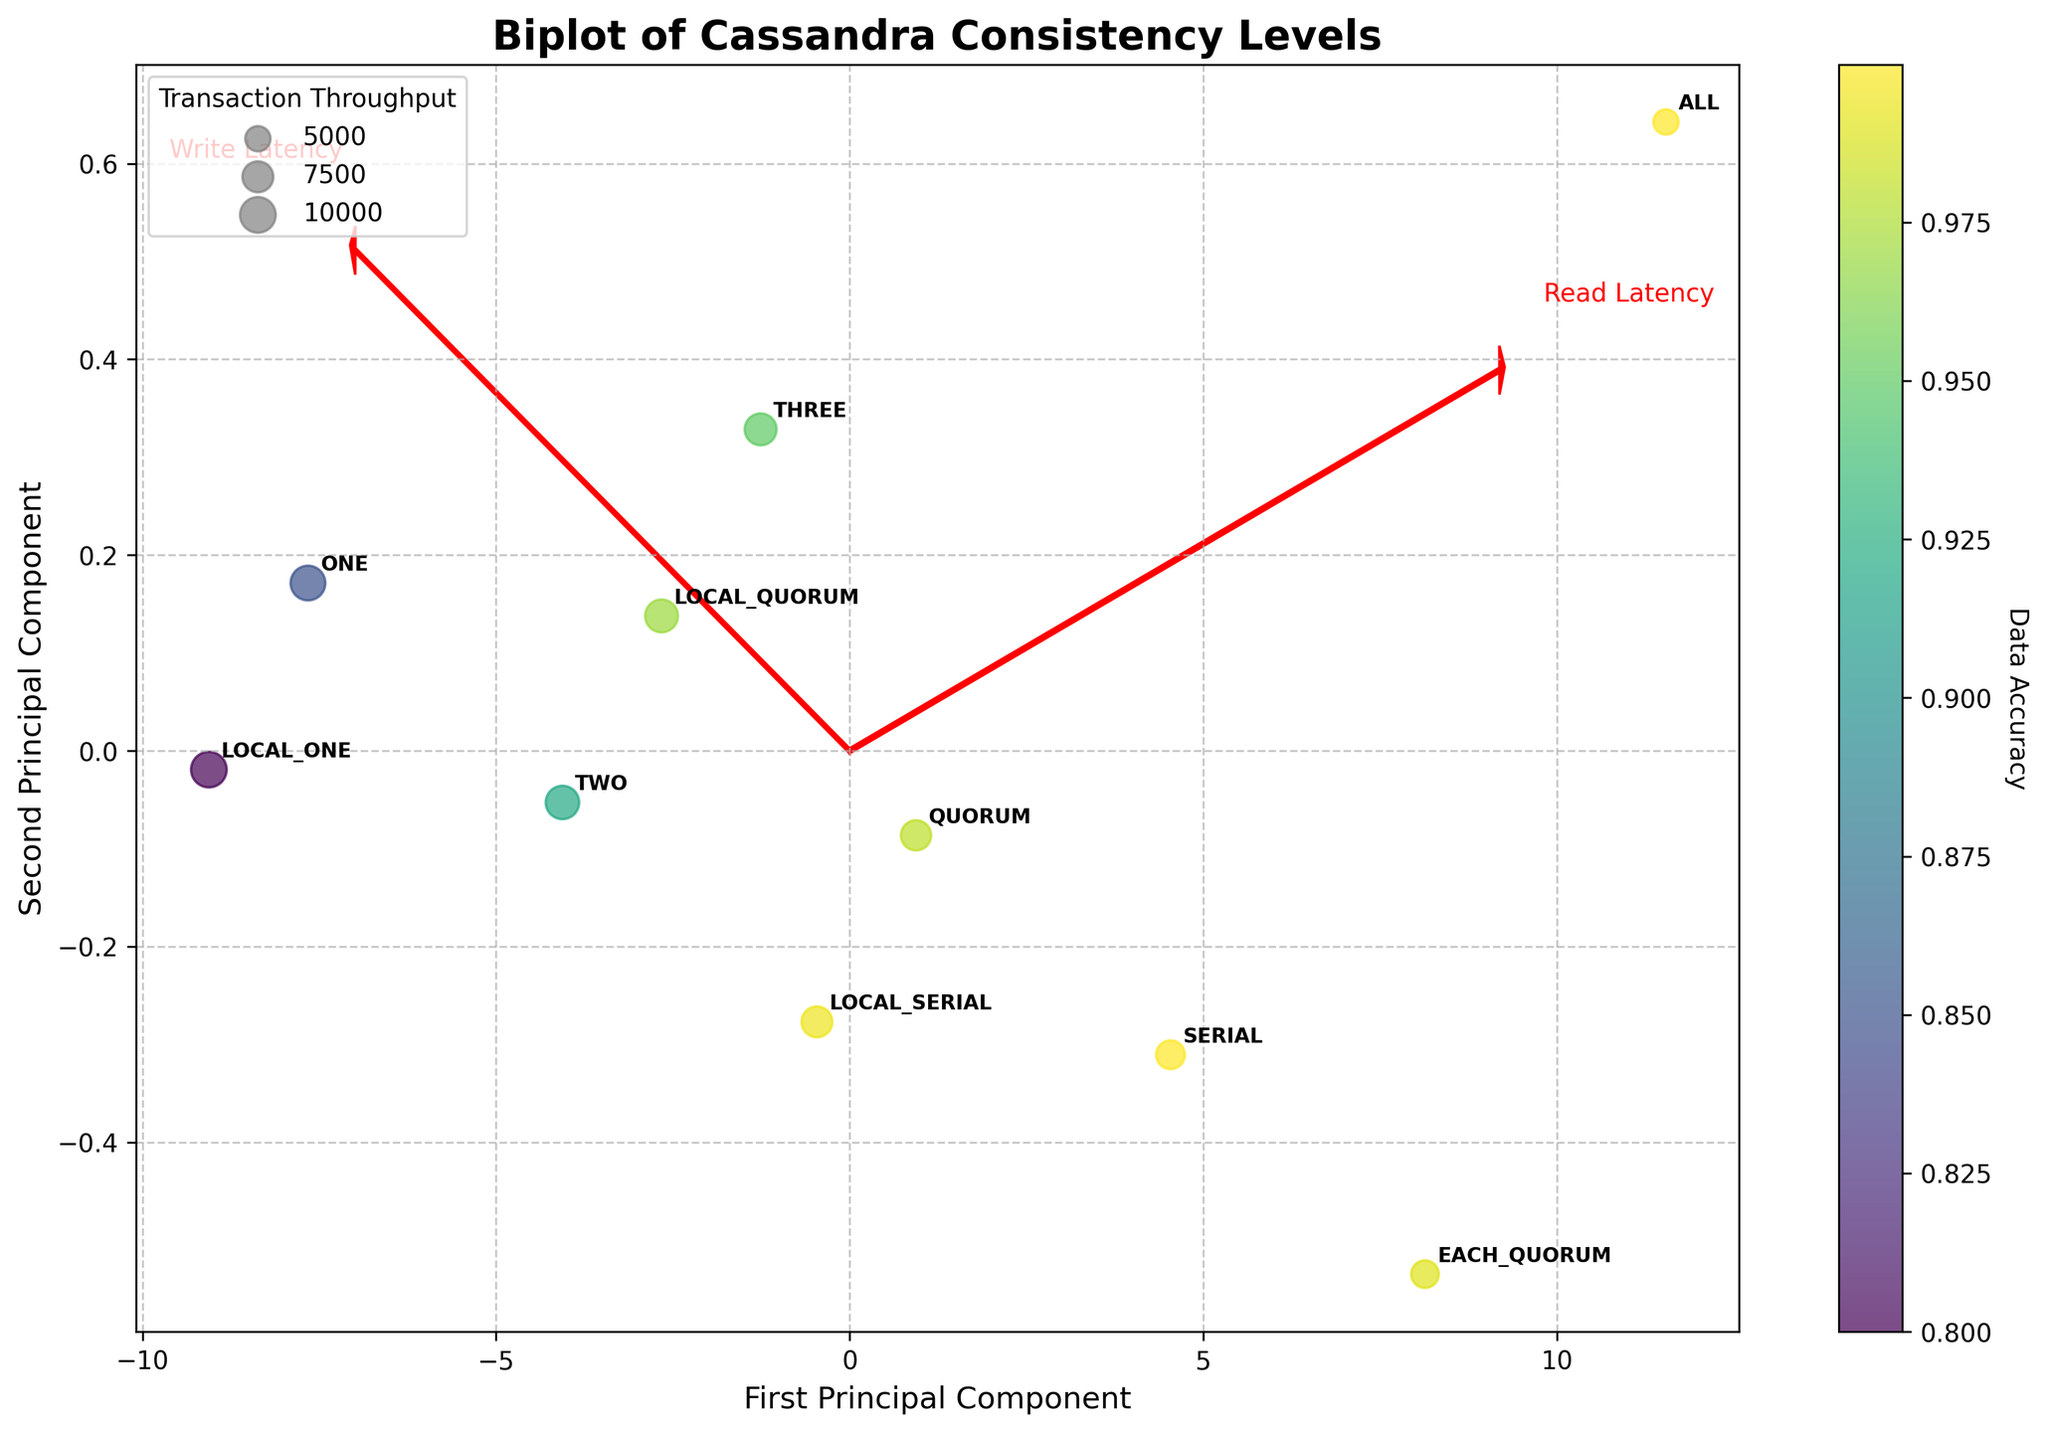What consistency level has the lowest read latency? Looking at the plot, we see that the consistency level labeled as LOCAL_ONE is closest to the origin on the x-axis, which signifies the lowest read latency.
Answer: LOCAL_ONE Which consistency level has the highest data accuracy? The color bar indicates that darker colors represent higher data accuracy. The consistency level ALL has the darkest color compared to others, indicating it has the highest data accuracy.
Answer: ALL What are the principal components labeled on the vectors in the plot? The plot has two vectors labeled as Read Latency and Write Latency, represented by arrows originating from the origin in the plot.
Answer: Read Latency and Write Latency Which consistency level has the highest transaction throughput? The size of the bubbles represents transaction throughput. The largest bubble represents the highest transaction throughput, which corresponds to the consistency level LOCAL_ONE.
Answer: LOCAL_ONE Compare the read and write latencies of consistency level SERIAL. In the plot, the SERIAL consistency level is positioned such that its projections on the Read Latency (x-axis) and Write Latency (y-axis) components can be compared. The read latency is higher than the write latency for SERIAL, indicated by its further distance along the x-axis than the y-axis.
Answer: Read latency is higher than write latency How does the transaction throughput of consistency level ONE compare to that of consistency level QUORUM? The bubbles representing transaction throughputs indicate that the ONE consistency level has a larger bubble compared to QUORUM, implying a higher transaction throughput. ONE has a value close to 9500 while QUORUM is around 7200.
Answer: ONE has higher throughput than QUORUM Is there a noticeable trade-off between latency and data accuracy in the plot? Observing the plot as latency increases (moving away from the origin along both axes), data accuracy tends to increase (colors get darker). This indicates a trade-off; lower latencies correspond to less data accuracy and higher latencies to higher accuracy.
Answer: Yes How does the performance of consistency level LOCAL_QUORUM compare in terms of read and write latency? The LOCAL_QUORUM consistency level is positioned within the plot such that its x (read latency) and y (write latency) coordinates can be directly seen. LOCAL_QUORUM has a read latency of 9 ms and a write latency of 6 ms, indicating read latency is higher than write latency.
Answer: Read latency is higher than write latency Which consistency level has read and write latencies closest to each other? By comparing the plot positions, consistency level TWO has read and write latencies (8 ms and 5 ms respectively) which are relatively close to each other, unlike others that show significant differences.
Answer: TWO 